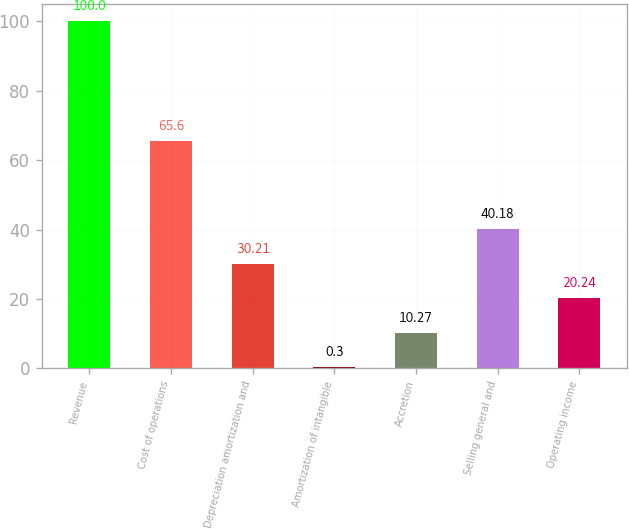Convert chart to OTSL. <chart><loc_0><loc_0><loc_500><loc_500><bar_chart><fcel>Revenue<fcel>Cost of operations<fcel>Depreciation amortization and<fcel>Amortization of intangible<fcel>Accretion<fcel>Selling general and<fcel>Operating income<nl><fcel>100<fcel>65.6<fcel>30.21<fcel>0.3<fcel>10.27<fcel>40.18<fcel>20.24<nl></chart> 